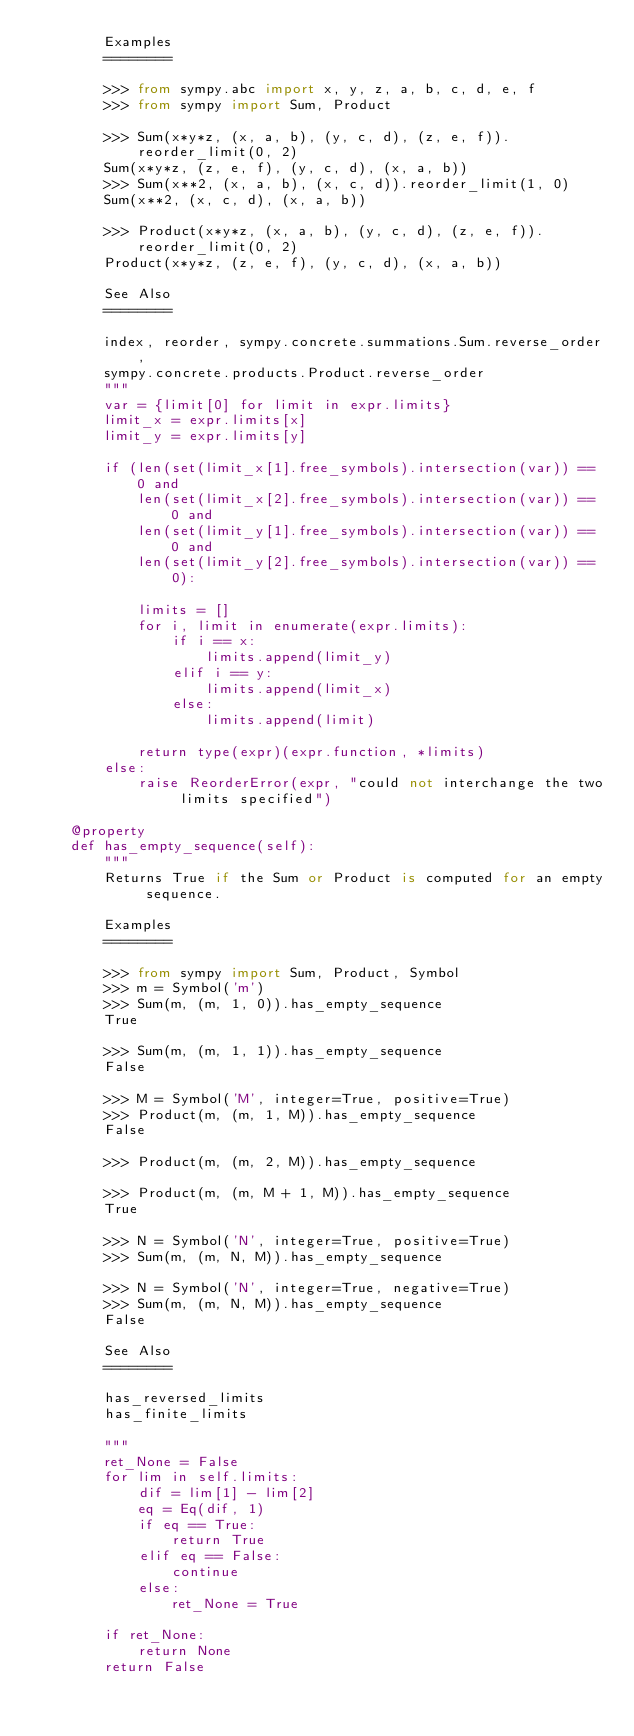<code> <loc_0><loc_0><loc_500><loc_500><_Python_>        Examples
        ========

        >>> from sympy.abc import x, y, z, a, b, c, d, e, f
        >>> from sympy import Sum, Product

        >>> Sum(x*y*z, (x, a, b), (y, c, d), (z, e, f)).reorder_limit(0, 2)
        Sum(x*y*z, (z, e, f), (y, c, d), (x, a, b))
        >>> Sum(x**2, (x, a, b), (x, c, d)).reorder_limit(1, 0)
        Sum(x**2, (x, c, d), (x, a, b))

        >>> Product(x*y*z, (x, a, b), (y, c, d), (z, e, f)).reorder_limit(0, 2)
        Product(x*y*z, (z, e, f), (y, c, d), (x, a, b))

        See Also
        ========

        index, reorder, sympy.concrete.summations.Sum.reverse_order,
        sympy.concrete.products.Product.reverse_order
        """
        var = {limit[0] for limit in expr.limits}
        limit_x = expr.limits[x]
        limit_y = expr.limits[y]

        if (len(set(limit_x[1].free_symbols).intersection(var)) == 0 and
            len(set(limit_x[2].free_symbols).intersection(var)) == 0 and
            len(set(limit_y[1].free_symbols).intersection(var)) == 0 and
            len(set(limit_y[2].free_symbols).intersection(var)) == 0):

            limits = []
            for i, limit in enumerate(expr.limits):
                if i == x:
                    limits.append(limit_y)
                elif i == y:
                    limits.append(limit_x)
                else:
                    limits.append(limit)

            return type(expr)(expr.function, *limits)
        else:
            raise ReorderError(expr, "could not interchange the two limits specified")

    @property
    def has_empty_sequence(self):
        """
        Returns True if the Sum or Product is computed for an empty sequence.

        Examples
        ========

        >>> from sympy import Sum, Product, Symbol
        >>> m = Symbol('m')
        >>> Sum(m, (m, 1, 0)).has_empty_sequence
        True

        >>> Sum(m, (m, 1, 1)).has_empty_sequence
        False

        >>> M = Symbol('M', integer=True, positive=True)
        >>> Product(m, (m, 1, M)).has_empty_sequence
        False

        >>> Product(m, (m, 2, M)).has_empty_sequence

        >>> Product(m, (m, M + 1, M)).has_empty_sequence
        True

        >>> N = Symbol('N', integer=True, positive=True)
        >>> Sum(m, (m, N, M)).has_empty_sequence

        >>> N = Symbol('N', integer=True, negative=True)
        >>> Sum(m, (m, N, M)).has_empty_sequence
        False

        See Also
        ========

        has_reversed_limits
        has_finite_limits

        """
        ret_None = False
        for lim in self.limits:
            dif = lim[1] - lim[2]
            eq = Eq(dif, 1)
            if eq == True:
                return True
            elif eq == False:
                continue
            else:
                ret_None = True

        if ret_None:
            return None
        return False
</code> 